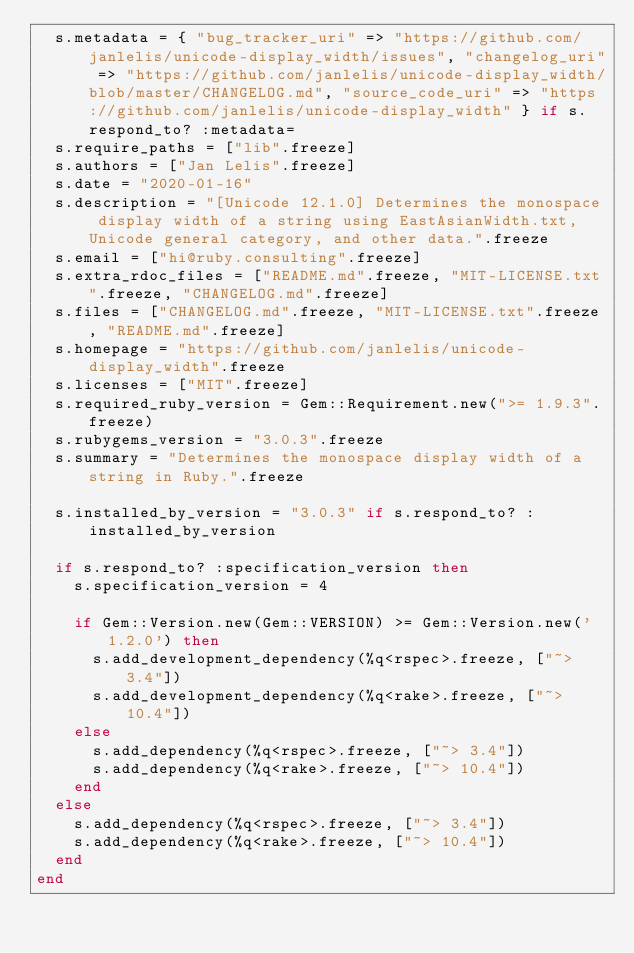<code> <loc_0><loc_0><loc_500><loc_500><_Ruby_>  s.metadata = { "bug_tracker_uri" => "https://github.com/janlelis/unicode-display_width/issues", "changelog_uri" => "https://github.com/janlelis/unicode-display_width/blob/master/CHANGELOG.md", "source_code_uri" => "https://github.com/janlelis/unicode-display_width" } if s.respond_to? :metadata=
  s.require_paths = ["lib".freeze]
  s.authors = ["Jan Lelis".freeze]
  s.date = "2020-01-16"
  s.description = "[Unicode 12.1.0] Determines the monospace display width of a string using EastAsianWidth.txt, Unicode general category, and other data.".freeze
  s.email = ["hi@ruby.consulting".freeze]
  s.extra_rdoc_files = ["README.md".freeze, "MIT-LICENSE.txt".freeze, "CHANGELOG.md".freeze]
  s.files = ["CHANGELOG.md".freeze, "MIT-LICENSE.txt".freeze, "README.md".freeze]
  s.homepage = "https://github.com/janlelis/unicode-display_width".freeze
  s.licenses = ["MIT".freeze]
  s.required_ruby_version = Gem::Requirement.new(">= 1.9.3".freeze)
  s.rubygems_version = "3.0.3".freeze
  s.summary = "Determines the monospace display width of a string in Ruby.".freeze

  s.installed_by_version = "3.0.3" if s.respond_to? :installed_by_version

  if s.respond_to? :specification_version then
    s.specification_version = 4

    if Gem::Version.new(Gem::VERSION) >= Gem::Version.new('1.2.0') then
      s.add_development_dependency(%q<rspec>.freeze, ["~> 3.4"])
      s.add_development_dependency(%q<rake>.freeze, ["~> 10.4"])
    else
      s.add_dependency(%q<rspec>.freeze, ["~> 3.4"])
      s.add_dependency(%q<rake>.freeze, ["~> 10.4"])
    end
  else
    s.add_dependency(%q<rspec>.freeze, ["~> 3.4"])
    s.add_dependency(%q<rake>.freeze, ["~> 10.4"])
  end
end
</code> 